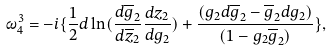<formula> <loc_0><loc_0><loc_500><loc_500>\omega _ { 4 } ^ { 3 } = - i \{ \frac { 1 } { 2 } d \ln ( \frac { d \overline { g } _ { 2 } } { d \overline { z } _ { 2 } } \frac { d z _ { 2 } } { d g _ { 2 } } ) + \frac { ( g _ { 2 } d \overline { g } _ { 2 } - \overline { g } _ { 2 } d g _ { 2 } ) } { ( 1 - g _ { 2 } \overline { g } _ { 2 } ) } \} ,</formula> 